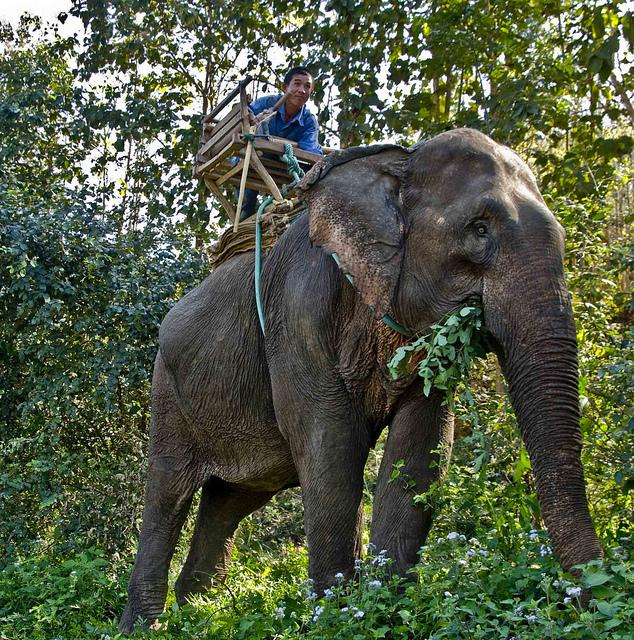How many people are on top of the elephant?
Concise answer only. 1. What is the elephant eating?
Short answer required. Leaves. What are the tall plants behind the elephants?
Be succinct. Trees. What's around the elephants neck?
Be succinct. Rope. What's helping the man sit on the back of the elephant?
Give a very brief answer. Chair. Is there someone sitting on top of an elephant?
Quick response, please. Yes. 